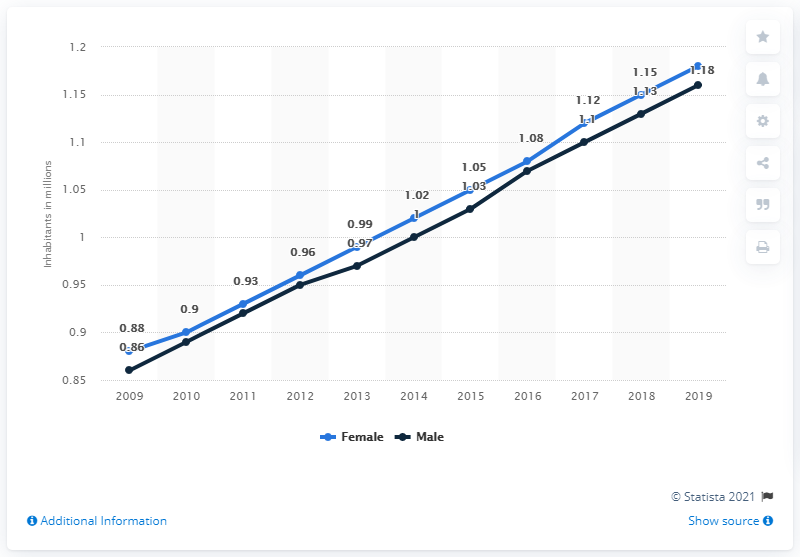List a handful of essential elements in this visual. According to the available data in 2019, the female population of the Gambia was estimated to be 1.18 million. The male population of the Gambia in 2019 was 1,160,000. 